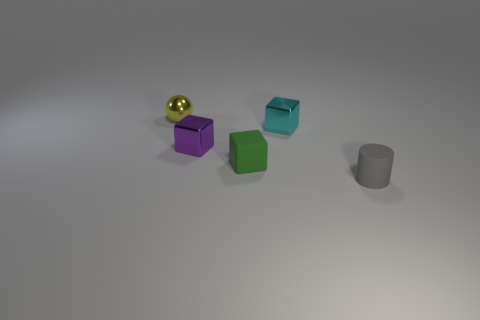There is a rubber thing that is on the left side of the tiny gray thing; what is its size?
Make the answer very short. Small. The small rubber object on the left side of the small matte thing that is right of the rubber object on the left side of the cyan shiny object is what shape?
Provide a succinct answer. Cube. How many other objects are the same shape as the small gray matte thing?
Your response must be concise. 0. How many rubber things are cyan blocks or small yellow spheres?
Your answer should be very brief. 0. What material is the tiny cube that is behind the small metallic block to the left of the cyan cube?
Make the answer very short. Metal. Is the number of objects in front of the purple cube greater than the number of big brown balls?
Provide a succinct answer. Yes. Are there any cyan blocks that have the same material as the cylinder?
Make the answer very short. No. There is a matte object in front of the matte cube; is its shape the same as the cyan object?
Offer a terse response. No. There is a tiny rubber thing that is on the left side of the tiny gray matte thing in front of the purple block; what number of rubber objects are in front of it?
Your response must be concise. 1. Is the number of gray cylinders that are behind the yellow metallic thing less than the number of metal objects on the left side of the cyan shiny cube?
Ensure brevity in your answer.  Yes. 